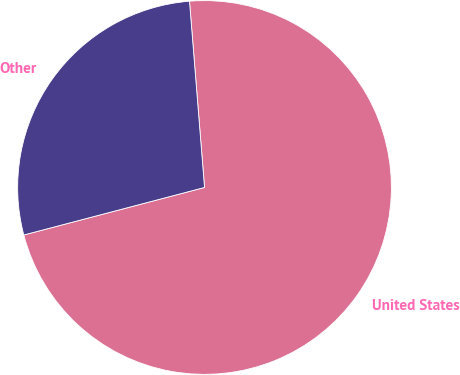Convert chart to OTSL. <chart><loc_0><loc_0><loc_500><loc_500><pie_chart><fcel>United States<fcel>Other<nl><fcel>72.19%<fcel>27.81%<nl></chart> 